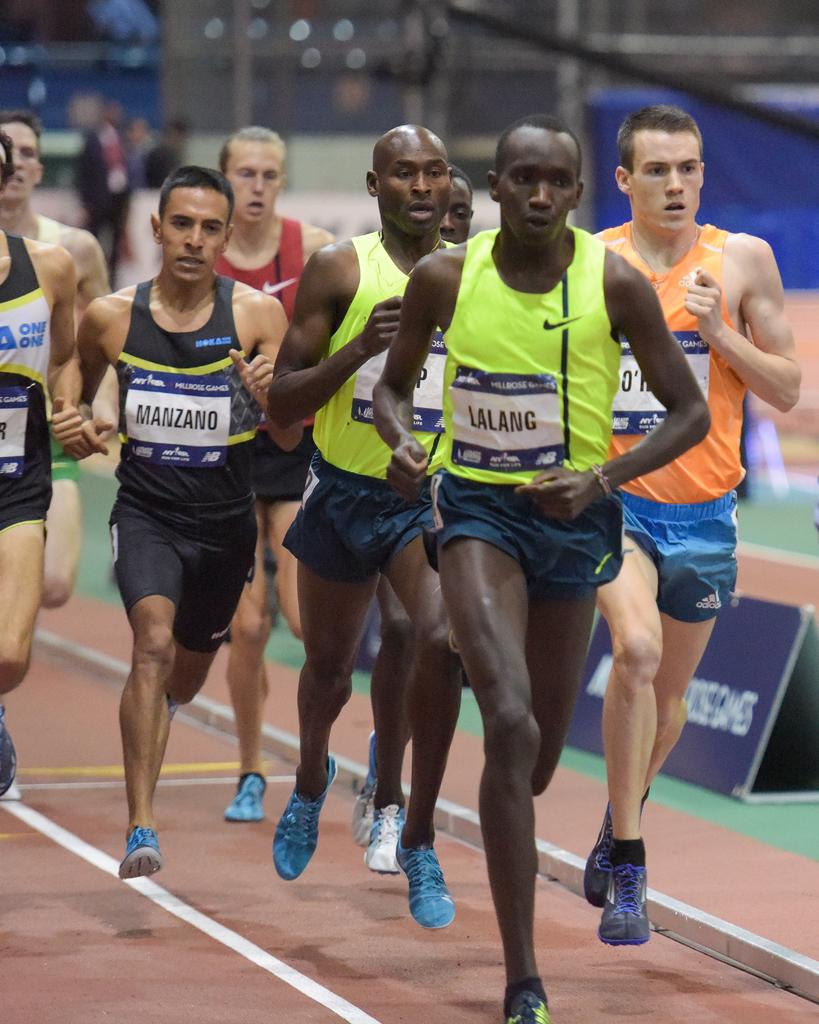What is the name of the runner on the left?
Your response must be concise. Manzano. 